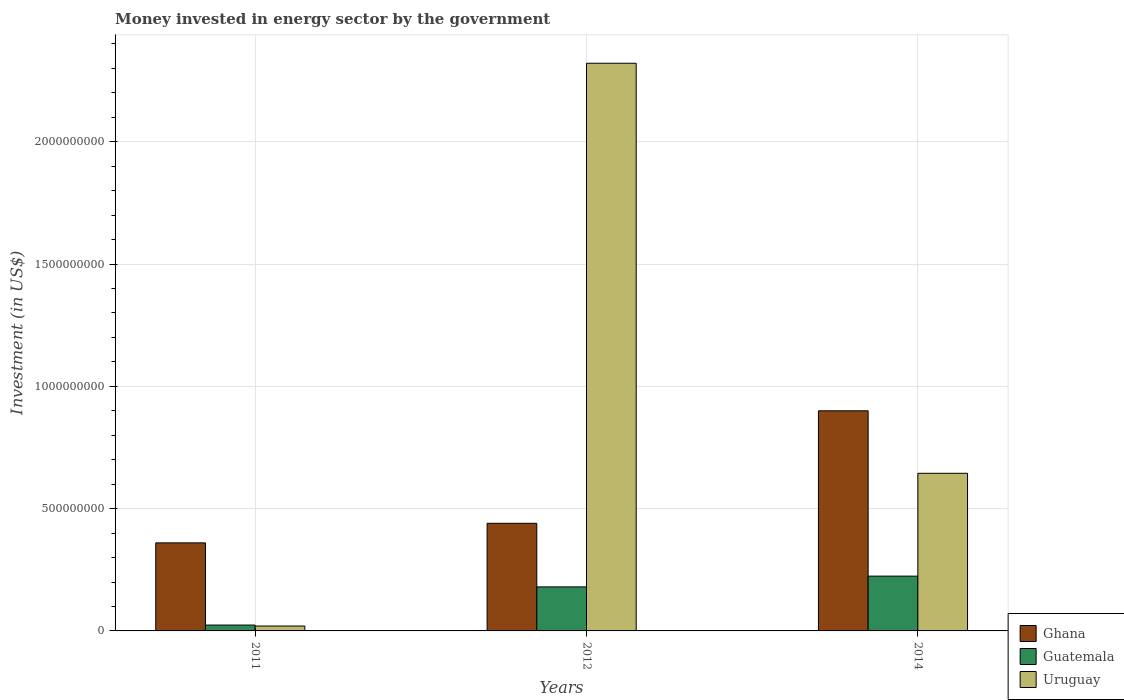How many groups of bars are there?
Provide a succinct answer. 3. Are the number of bars per tick equal to the number of legend labels?
Offer a terse response. Yes. How many bars are there on the 3rd tick from the right?
Your answer should be very brief. 3. In how many cases, is the number of bars for a given year not equal to the number of legend labels?
Your answer should be compact. 0. What is the money spent in energy sector in Guatemala in 2014?
Your answer should be compact. 2.24e+08. Across all years, what is the maximum money spent in energy sector in Guatemala?
Provide a succinct answer. 2.24e+08. Across all years, what is the minimum money spent in energy sector in Uruguay?
Give a very brief answer. 2.00e+07. In which year was the money spent in energy sector in Guatemala minimum?
Give a very brief answer. 2011. What is the total money spent in energy sector in Ghana in the graph?
Keep it short and to the point. 1.70e+09. What is the difference between the money spent in energy sector in Ghana in 2011 and that in 2012?
Provide a succinct answer. -8.00e+07. What is the difference between the money spent in energy sector in Ghana in 2014 and the money spent in energy sector in Guatemala in 2012?
Keep it short and to the point. 7.20e+08. What is the average money spent in energy sector in Guatemala per year?
Your response must be concise. 1.43e+08. In the year 2011, what is the difference between the money spent in energy sector in Ghana and money spent in energy sector in Uruguay?
Provide a succinct answer. 3.40e+08. In how many years, is the money spent in energy sector in Ghana greater than 2000000000 US$?
Offer a very short reply. 0. What is the ratio of the money spent in energy sector in Ghana in 2011 to that in 2012?
Provide a succinct answer. 0.82. What is the difference between the highest and the second highest money spent in energy sector in Guatemala?
Keep it short and to the point. 4.40e+07. What is the difference between the highest and the lowest money spent in energy sector in Guatemala?
Keep it short and to the point. 2.00e+08. Is the sum of the money spent in energy sector in Guatemala in 2011 and 2014 greater than the maximum money spent in energy sector in Uruguay across all years?
Keep it short and to the point. No. What does the 2nd bar from the left in 2012 represents?
Your answer should be compact. Guatemala. What does the 2nd bar from the right in 2012 represents?
Keep it short and to the point. Guatemala. How many bars are there?
Provide a succinct answer. 9. How many years are there in the graph?
Your response must be concise. 3. Does the graph contain any zero values?
Your response must be concise. No. How are the legend labels stacked?
Provide a short and direct response. Vertical. What is the title of the graph?
Provide a succinct answer. Money invested in energy sector by the government. Does "Guinea" appear as one of the legend labels in the graph?
Offer a very short reply. No. What is the label or title of the X-axis?
Make the answer very short. Years. What is the label or title of the Y-axis?
Provide a short and direct response. Investment (in US$). What is the Investment (in US$) of Ghana in 2011?
Give a very brief answer. 3.60e+08. What is the Investment (in US$) of Guatemala in 2011?
Offer a very short reply. 2.40e+07. What is the Investment (in US$) in Uruguay in 2011?
Give a very brief answer. 2.00e+07. What is the Investment (in US$) of Ghana in 2012?
Give a very brief answer. 4.40e+08. What is the Investment (in US$) in Guatemala in 2012?
Keep it short and to the point. 1.80e+08. What is the Investment (in US$) of Uruguay in 2012?
Make the answer very short. 2.32e+09. What is the Investment (in US$) of Ghana in 2014?
Provide a short and direct response. 9.00e+08. What is the Investment (in US$) of Guatemala in 2014?
Your answer should be compact. 2.24e+08. What is the Investment (in US$) of Uruguay in 2014?
Make the answer very short. 6.44e+08. Across all years, what is the maximum Investment (in US$) in Ghana?
Give a very brief answer. 9.00e+08. Across all years, what is the maximum Investment (in US$) in Guatemala?
Your answer should be compact. 2.24e+08. Across all years, what is the maximum Investment (in US$) in Uruguay?
Your answer should be very brief. 2.32e+09. Across all years, what is the minimum Investment (in US$) in Ghana?
Provide a short and direct response. 3.60e+08. Across all years, what is the minimum Investment (in US$) of Guatemala?
Make the answer very short. 2.40e+07. Across all years, what is the minimum Investment (in US$) in Uruguay?
Your answer should be very brief. 2.00e+07. What is the total Investment (in US$) of Ghana in the graph?
Provide a short and direct response. 1.70e+09. What is the total Investment (in US$) of Guatemala in the graph?
Ensure brevity in your answer.  4.28e+08. What is the total Investment (in US$) of Uruguay in the graph?
Provide a short and direct response. 2.99e+09. What is the difference between the Investment (in US$) of Ghana in 2011 and that in 2012?
Keep it short and to the point. -8.00e+07. What is the difference between the Investment (in US$) of Guatemala in 2011 and that in 2012?
Provide a short and direct response. -1.56e+08. What is the difference between the Investment (in US$) in Uruguay in 2011 and that in 2012?
Ensure brevity in your answer.  -2.30e+09. What is the difference between the Investment (in US$) of Ghana in 2011 and that in 2014?
Make the answer very short. -5.40e+08. What is the difference between the Investment (in US$) in Guatemala in 2011 and that in 2014?
Your response must be concise. -2.00e+08. What is the difference between the Investment (in US$) in Uruguay in 2011 and that in 2014?
Offer a terse response. -6.24e+08. What is the difference between the Investment (in US$) of Ghana in 2012 and that in 2014?
Your answer should be very brief. -4.60e+08. What is the difference between the Investment (in US$) in Guatemala in 2012 and that in 2014?
Keep it short and to the point. -4.40e+07. What is the difference between the Investment (in US$) of Uruguay in 2012 and that in 2014?
Offer a very short reply. 1.68e+09. What is the difference between the Investment (in US$) in Ghana in 2011 and the Investment (in US$) in Guatemala in 2012?
Make the answer very short. 1.80e+08. What is the difference between the Investment (in US$) of Ghana in 2011 and the Investment (in US$) of Uruguay in 2012?
Provide a short and direct response. -1.96e+09. What is the difference between the Investment (in US$) in Guatemala in 2011 and the Investment (in US$) in Uruguay in 2012?
Provide a succinct answer. -2.30e+09. What is the difference between the Investment (in US$) in Ghana in 2011 and the Investment (in US$) in Guatemala in 2014?
Give a very brief answer. 1.36e+08. What is the difference between the Investment (in US$) of Ghana in 2011 and the Investment (in US$) of Uruguay in 2014?
Keep it short and to the point. -2.84e+08. What is the difference between the Investment (in US$) of Guatemala in 2011 and the Investment (in US$) of Uruguay in 2014?
Provide a succinct answer. -6.20e+08. What is the difference between the Investment (in US$) of Ghana in 2012 and the Investment (in US$) of Guatemala in 2014?
Provide a short and direct response. 2.16e+08. What is the difference between the Investment (in US$) of Ghana in 2012 and the Investment (in US$) of Uruguay in 2014?
Keep it short and to the point. -2.04e+08. What is the difference between the Investment (in US$) of Guatemala in 2012 and the Investment (in US$) of Uruguay in 2014?
Your answer should be compact. -4.64e+08. What is the average Investment (in US$) of Ghana per year?
Make the answer very short. 5.67e+08. What is the average Investment (in US$) of Guatemala per year?
Make the answer very short. 1.43e+08. What is the average Investment (in US$) in Uruguay per year?
Your response must be concise. 9.95e+08. In the year 2011, what is the difference between the Investment (in US$) of Ghana and Investment (in US$) of Guatemala?
Keep it short and to the point. 3.36e+08. In the year 2011, what is the difference between the Investment (in US$) of Ghana and Investment (in US$) of Uruguay?
Your answer should be compact. 3.40e+08. In the year 2011, what is the difference between the Investment (in US$) of Guatemala and Investment (in US$) of Uruguay?
Your answer should be very brief. 4.00e+06. In the year 2012, what is the difference between the Investment (in US$) in Ghana and Investment (in US$) in Guatemala?
Make the answer very short. 2.60e+08. In the year 2012, what is the difference between the Investment (in US$) of Ghana and Investment (in US$) of Uruguay?
Your answer should be compact. -1.88e+09. In the year 2012, what is the difference between the Investment (in US$) of Guatemala and Investment (in US$) of Uruguay?
Your answer should be compact. -2.14e+09. In the year 2014, what is the difference between the Investment (in US$) in Ghana and Investment (in US$) in Guatemala?
Provide a short and direct response. 6.76e+08. In the year 2014, what is the difference between the Investment (in US$) in Ghana and Investment (in US$) in Uruguay?
Your response must be concise. 2.56e+08. In the year 2014, what is the difference between the Investment (in US$) of Guatemala and Investment (in US$) of Uruguay?
Your answer should be compact. -4.20e+08. What is the ratio of the Investment (in US$) in Ghana in 2011 to that in 2012?
Your response must be concise. 0.82. What is the ratio of the Investment (in US$) of Guatemala in 2011 to that in 2012?
Offer a very short reply. 0.13. What is the ratio of the Investment (in US$) of Uruguay in 2011 to that in 2012?
Provide a short and direct response. 0.01. What is the ratio of the Investment (in US$) of Ghana in 2011 to that in 2014?
Your response must be concise. 0.4. What is the ratio of the Investment (in US$) in Guatemala in 2011 to that in 2014?
Provide a succinct answer. 0.11. What is the ratio of the Investment (in US$) of Uruguay in 2011 to that in 2014?
Your answer should be very brief. 0.03. What is the ratio of the Investment (in US$) of Ghana in 2012 to that in 2014?
Make the answer very short. 0.49. What is the ratio of the Investment (in US$) of Guatemala in 2012 to that in 2014?
Provide a succinct answer. 0.8. What is the ratio of the Investment (in US$) in Uruguay in 2012 to that in 2014?
Ensure brevity in your answer.  3.6. What is the difference between the highest and the second highest Investment (in US$) in Ghana?
Offer a very short reply. 4.60e+08. What is the difference between the highest and the second highest Investment (in US$) in Guatemala?
Give a very brief answer. 4.40e+07. What is the difference between the highest and the second highest Investment (in US$) of Uruguay?
Your answer should be compact. 1.68e+09. What is the difference between the highest and the lowest Investment (in US$) of Ghana?
Offer a very short reply. 5.40e+08. What is the difference between the highest and the lowest Investment (in US$) in Uruguay?
Make the answer very short. 2.30e+09. 